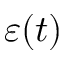Convert formula to latex. <formula><loc_0><loc_0><loc_500><loc_500>\varepsilon ( t )</formula> 